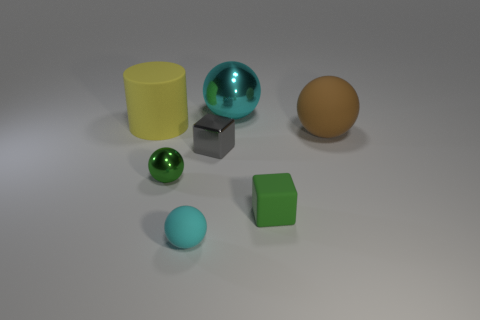Can you create a simple story involving these objects? Certainly! In a world where shapes have their unique personalities, there's a group of friends who live on the plains of Polygonia. The green and blue spheres are the optimists of the group, rolling around and spreading cheer. The shiny teal sphere is the adventurer, always gleaming with stories of metallic mountains. The yellow cylinder is the thinker, often pondering over the Container Canyons, while the wooden brown object is the wise one, imparting wisdom from the ancient Tree of Craft. Together, they embark on a journey to help the little gray cube find its lost edges, meeting new angular friends and overcoming the obstacles of the Great Plane. 